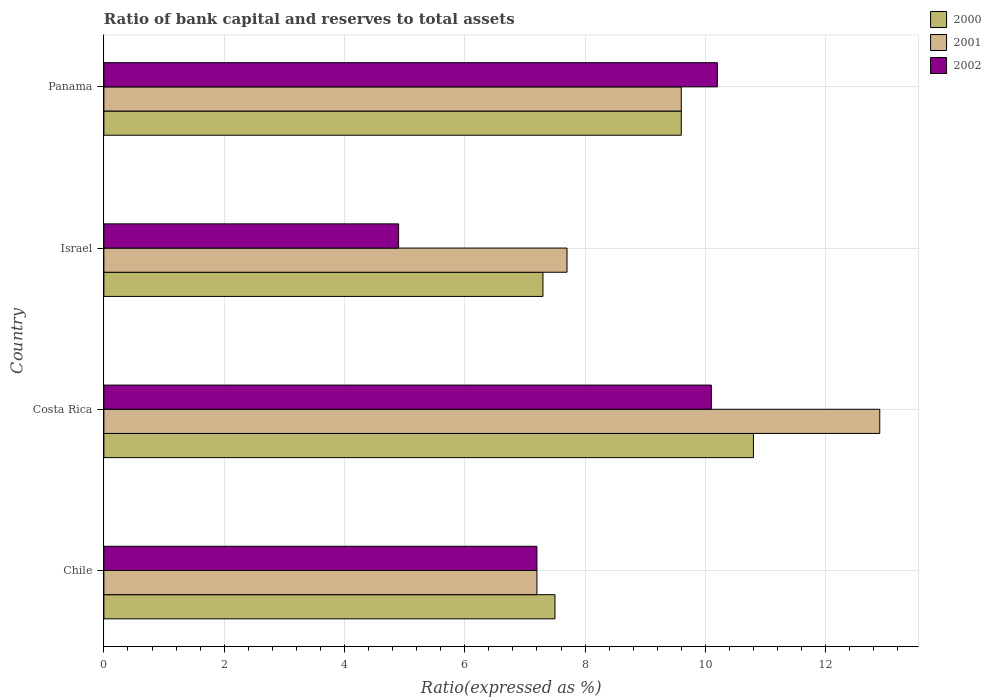How many different coloured bars are there?
Ensure brevity in your answer.  3. How many groups of bars are there?
Offer a very short reply. 4. Are the number of bars on each tick of the Y-axis equal?
Provide a short and direct response. Yes. How many bars are there on the 3rd tick from the top?
Ensure brevity in your answer.  3. What is the label of the 2nd group of bars from the top?
Make the answer very short. Israel. In how many cases, is the number of bars for a given country not equal to the number of legend labels?
Give a very brief answer. 0. What is the ratio of bank capital and reserves to total assets in 2001 in Israel?
Make the answer very short. 7.7. In which country was the ratio of bank capital and reserves to total assets in 2000 maximum?
Ensure brevity in your answer.  Costa Rica. What is the total ratio of bank capital and reserves to total assets in 2001 in the graph?
Keep it short and to the point. 37.4. What is the difference between the ratio of bank capital and reserves to total assets in 2001 in Chile and that in Israel?
Ensure brevity in your answer.  -0.5. What is the difference between the ratio of bank capital and reserves to total assets in 2002 in Panama and the ratio of bank capital and reserves to total assets in 2001 in Costa Rica?
Your response must be concise. -2.7. What is the average ratio of bank capital and reserves to total assets in 2001 per country?
Your answer should be compact. 9.35. What is the difference between the ratio of bank capital and reserves to total assets in 2002 and ratio of bank capital and reserves to total assets in 2001 in Panama?
Provide a short and direct response. 0.6. What is the ratio of the ratio of bank capital and reserves to total assets in 2002 in Chile to that in Panama?
Give a very brief answer. 0.71. What is the difference between the highest and the second highest ratio of bank capital and reserves to total assets in 2001?
Your answer should be compact. 3.3. In how many countries, is the ratio of bank capital and reserves to total assets in 2000 greater than the average ratio of bank capital and reserves to total assets in 2000 taken over all countries?
Your answer should be very brief. 2. What does the 3rd bar from the top in Israel represents?
Ensure brevity in your answer.  2000. What does the 3rd bar from the bottom in Panama represents?
Your answer should be compact. 2002. Are the values on the major ticks of X-axis written in scientific E-notation?
Offer a terse response. No. Does the graph contain any zero values?
Your answer should be compact. No. Does the graph contain grids?
Your answer should be compact. Yes. How many legend labels are there?
Provide a short and direct response. 3. What is the title of the graph?
Ensure brevity in your answer.  Ratio of bank capital and reserves to total assets. What is the label or title of the X-axis?
Provide a succinct answer. Ratio(expressed as %). What is the label or title of the Y-axis?
Make the answer very short. Country. What is the Ratio(expressed as %) of 2000 in Chile?
Your answer should be compact. 7.5. What is the Ratio(expressed as %) in 2002 in Chile?
Ensure brevity in your answer.  7.2. What is the Ratio(expressed as %) in 2000 in Costa Rica?
Offer a very short reply. 10.8. What is the Ratio(expressed as %) of 2001 in Costa Rica?
Your response must be concise. 12.9. What is the Ratio(expressed as %) in 2002 in Costa Rica?
Keep it short and to the point. 10.1. What is the Ratio(expressed as %) of 2001 in Israel?
Make the answer very short. 7.7. Across all countries, what is the maximum Ratio(expressed as %) of 2000?
Your answer should be compact. 10.8. Across all countries, what is the maximum Ratio(expressed as %) of 2002?
Your answer should be very brief. 10.2. Across all countries, what is the minimum Ratio(expressed as %) in 2001?
Keep it short and to the point. 7.2. Across all countries, what is the minimum Ratio(expressed as %) of 2002?
Keep it short and to the point. 4.9. What is the total Ratio(expressed as %) of 2000 in the graph?
Offer a very short reply. 35.2. What is the total Ratio(expressed as %) in 2001 in the graph?
Give a very brief answer. 37.4. What is the total Ratio(expressed as %) of 2002 in the graph?
Provide a short and direct response. 32.4. What is the difference between the Ratio(expressed as %) of 2000 in Chile and that in Israel?
Give a very brief answer. 0.2. What is the difference between the Ratio(expressed as %) of 2002 in Chile and that in Israel?
Provide a succinct answer. 2.3. What is the difference between the Ratio(expressed as %) of 2000 in Chile and that in Panama?
Your answer should be compact. -2.1. What is the difference between the Ratio(expressed as %) of 2001 in Chile and that in Panama?
Your answer should be compact. -2.4. What is the difference between the Ratio(expressed as %) of 2002 in Chile and that in Panama?
Give a very brief answer. -3. What is the difference between the Ratio(expressed as %) of 2000 in Costa Rica and that in Panama?
Provide a short and direct response. 1.2. What is the difference between the Ratio(expressed as %) of 2002 in Costa Rica and that in Panama?
Offer a terse response. -0.1. What is the difference between the Ratio(expressed as %) in 2001 in Israel and that in Panama?
Your answer should be very brief. -1.9. What is the difference between the Ratio(expressed as %) in 2000 in Chile and the Ratio(expressed as %) in 2001 in Costa Rica?
Provide a short and direct response. -5.4. What is the difference between the Ratio(expressed as %) in 2001 in Chile and the Ratio(expressed as %) in 2002 in Costa Rica?
Offer a terse response. -2.9. What is the difference between the Ratio(expressed as %) of 2000 in Chile and the Ratio(expressed as %) of 2001 in Israel?
Provide a short and direct response. -0.2. What is the difference between the Ratio(expressed as %) in 2000 in Chile and the Ratio(expressed as %) in 2002 in Israel?
Make the answer very short. 2.6. What is the difference between the Ratio(expressed as %) in 2001 in Chile and the Ratio(expressed as %) in 2002 in Israel?
Provide a short and direct response. 2.3. What is the difference between the Ratio(expressed as %) of 2000 in Chile and the Ratio(expressed as %) of 2001 in Panama?
Keep it short and to the point. -2.1. What is the difference between the Ratio(expressed as %) in 2000 in Chile and the Ratio(expressed as %) in 2002 in Panama?
Ensure brevity in your answer.  -2.7. What is the difference between the Ratio(expressed as %) in 2000 in Costa Rica and the Ratio(expressed as %) in 2001 in Israel?
Your response must be concise. 3.1. What is the difference between the Ratio(expressed as %) in 2000 in Costa Rica and the Ratio(expressed as %) in 2002 in Israel?
Offer a very short reply. 5.9. What is the difference between the Ratio(expressed as %) of 2001 in Costa Rica and the Ratio(expressed as %) of 2002 in Israel?
Provide a succinct answer. 8. What is the difference between the Ratio(expressed as %) of 2000 in Israel and the Ratio(expressed as %) of 2001 in Panama?
Keep it short and to the point. -2.3. What is the difference between the Ratio(expressed as %) in 2001 in Israel and the Ratio(expressed as %) in 2002 in Panama?
Your answer should be compact. -2.5. What is the average Ratio(expressed as %) in 2000 per country?
Your answer should be very brief. 8.8. What is the average Ratio(expressed as %) of 2001 per country?
Your answer should be compact. 9.35. What is the difference between the Ratio(expressed as %) of 2000 and Ratio(expressed as %) of 2001 in Chile?
Your answer should be very brief. 0.3. What is the difference between the Ratio(expressed as %) of 2000 and Ratio(expressed as %) of 2002 in Chile?
Your response must be concise. 0.3. What is the difference between the Ratio(expressed as %) of 2000 and Ratio(expressed as %) of 2002 in Costa Rica?
Keep it short and to the point. 0.7. What is the difference between the Ratio(expressed as %) in 2000 and Ratio(expressed as %) in 2001 in Israel?
Keep it short and to the point. -0.4. What is the difference between the Ratio(expressed as %) in 2000 and Ratio(expressed as %) in 2002 in Israel?
Provide a short and direct response. 2.4. What is the difference between the Ratio(expressed as %) in 2000 and Ratio(expressed as %) in 2002 in Panama?
Offer a terse response. -0.6. What is the ratio of the Ratio(expressed as %) of 2000 in Chile to that in Costa Rica?
Your response must be concise. 0.69. What is the ratio of the Ratio(expressed as %) in 2001 in Chile to that in Costa Rica?
Make the answer very short. 0.56. What is the ratio of the Ratio(expressed as %) in 2002 in Chile to that in Costa Rica?
Your answer should be very brief. 0.71. What is the ratio of the Ratio(expressed as %) in 2000 in Chile to that in Israel?
Keep it short and to the point. 1.03. What is the ratio of the Ratio(expressed as %) in 2001 in Chile to that in Israel?
Your answer should be very brief. 0.94. What is the ratio of the Ratio(expressed as %) of 2002 in Chile to that in Israel?
Offer a very short reply. 1.47. What is the ratio of the Ratio(expressed as %) of 2000 in Chile to that in Panama?
Offer a terse response. 0.78. What is the ratio of the Ratio(expressed as %) in 2001 in Chile to that in Panama?
Give a very brief answer. 0.75. What is the ratio of the Ratio(expressed as %) in 2002 in Chile to that in Panama?
Give a very brief answer. 0.71. What is the ratio of the Ratio(expressed as %) in 2000 in Costa Rica to that in Israel?
Ensure brevity in your answer.  1.48. What is the ratio of the Ratio(expressed as %) of 2001 in Costa Rica to that in Israel?
Provide a succinct answer. 1.68. What is the ratio of the Ratio(expressed as %) of 2002 in Costa Rica to that in Israel?
Make the answer very short. 2.06. What is the ratio of the Ratio(expressed as %) in 2000 in Costa Rica to that in Panama?
Your answer should be compact. 1.12. What is the ratio of the Ratio(expressed as %) in 2001 in Costa Rica to that in Panama?
Give a very brief answer. 1.34. What is the ratio of the Ratio(expressed as %) in 2002 in Costa Rica to that in Panama?
Give a very brief answer. 0.99. What is the ratio of the Ratio(expressed as %) of 2000 in Israel to that in Panama?
Make the answer very short. 0.76. What is the ratio of the Ratio(expressed as %) of 2001 in Israel to that in Panama?
Keep it short and to the point. 0.8. What is the ratio of the Ratio(expressed as %) of 2002 in Israel to that in Panama?
Your answer should be compact. 0.48. What is the difference between the highest and the second highest Ratio(expressed as %) of 2000?
Ensure brevity in your answer.  1.2. What is the difference between the highest and the second highest Ratio(expressed as %) in 2001?
Offer a very short reply. 3.3. What is the difference between the highest and the lowest Ratio(expressed as %) in 2001?
Provide a short and direct response. 5.7. 